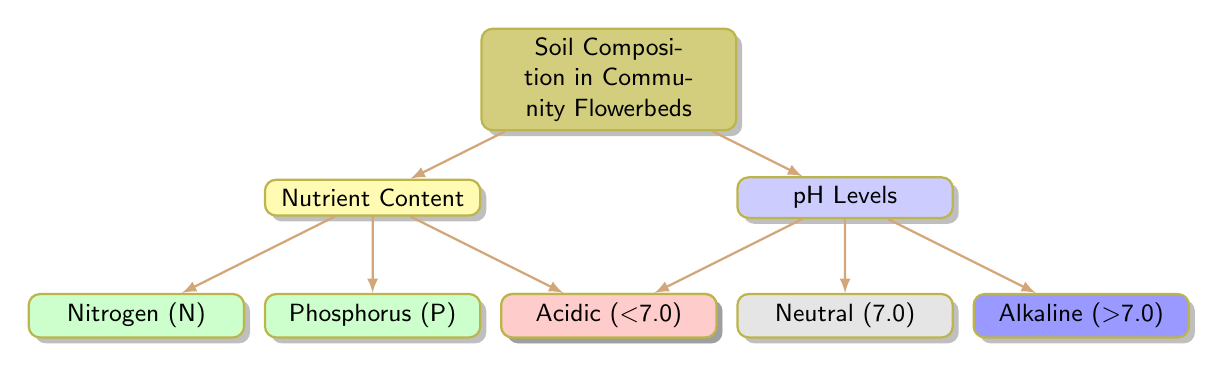What are the three main categories of soil composition presented in the diagram? The diagram has two primary branches: Nutrient Content and pH Levels. Under Nutrient Content, there are three specific nutrients mentioned: Nitrogen, Phosphorus, and Potassium. Therefore, the three main categories are Nutrient Content, pH Levels, and Soil Composition.
Answer: Nutrient Content, pH Levels How many nutrient types are listed in the diagram? Under the Nutrient Content category, three types of nutrients are listed: Nitrogen, Phosphorus, and Potassium. Thus, the number of nutrient types is three.
Answer: Three What is the pH level category that is less than 7.0? The diagram categorizes pH levels into Acidic, Neutral, and Alkaline. The category that indicates a pH level less than 7.0 is Acidic.
Answer: Acidic Which nutrient appears first in the Nutrient Content section? In the Nutrient Content section, the nutrients are presented in the following order: Nitrogen, then Phosphorus, followed by Potassium. The first nutrient mentioned is Nitrogen.
Answer: Nitrogen What is the relationship between Nutrient Content and the specific nutrients listed? Nutrient Content is the parent node, while Nitrogen, Phosphorus, and Potassium are its child nodes. This structure indicates that these specific nutrients are subcategories or components of the broader Nutrient Content classification.
Answer: Parent-child relationship How many different pH level categories are shown? There are three pH level categories in the diagram: Acidic, Neutral, and Alkaline. Therefore, the total number of different pH level categories is three.
Answer: Three What is the numerical value associated with the Neutral pH level category? The diagram states the Neutral pH level is identified as 7.0, which is a specific value referring to neutrality in pH measurement.
Answer: 7.0 Which nutrient category is shown in yellow? The color yellow is used in the diagram to represent the Nutrient Content category. Thus, the nutrient category that is shown in yellow is Nutrient Content.
Answer: Nutrient Content What color represents the Alkaline pH level in the diagram? In the diagram, the Alkaline pH level is indicated with the color blue. Therefore, the color that represents Alkaline is blue.
Answer: Blue 